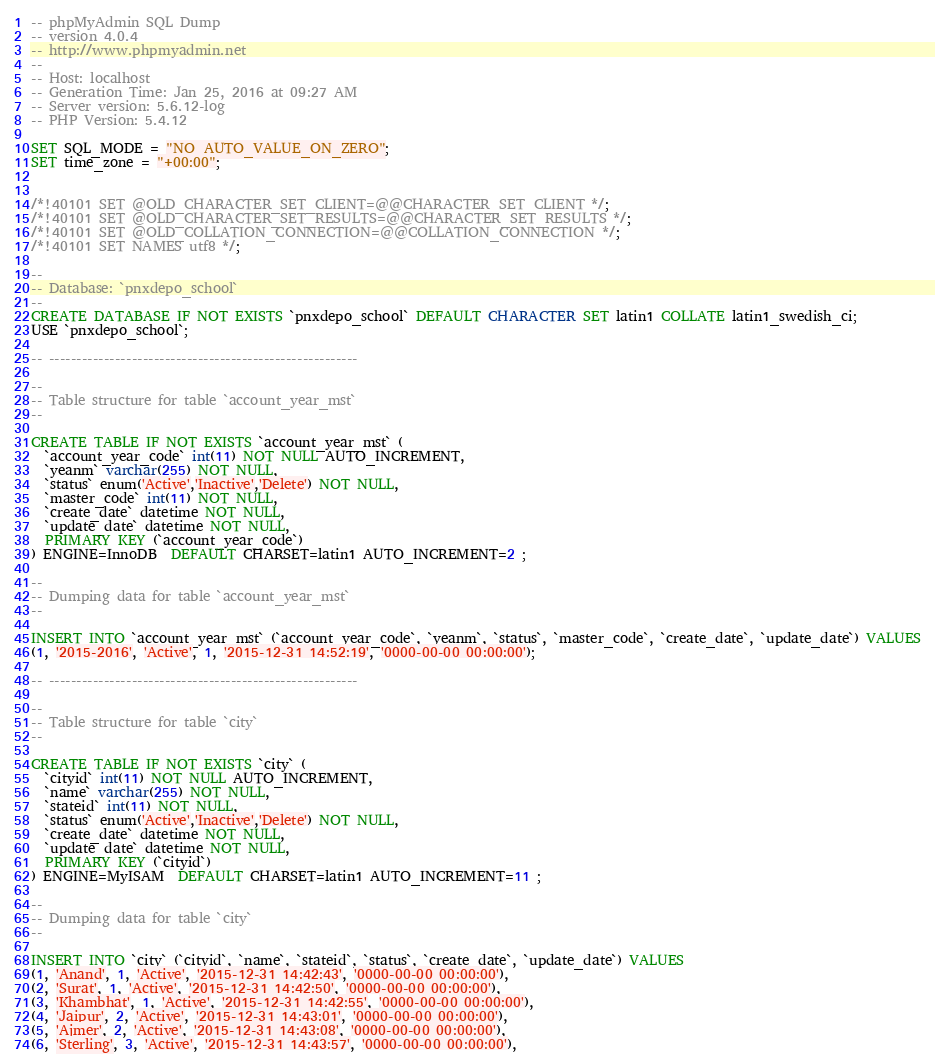<code> <loc_0><loc_0><loc_500><loc_500><_SQL_>-- phpMyAdmin SQL Dump
-- version 4.0.4
-- http://www.phpmyadmin.net
--
-- Host: localhost
-- Generation Time: Jan 25, 2016 at 09:27 AM
-- Server version: 5.6.12-log
-- PHP Version: 5.4.12

SET SQL_MODE = "NO_AUTO_VALUE_ON_ZERO";
SET time_zone = "+00:00";


/*!40101 SET @OLD_CHARACTER_SET_CLIENT=@@CHARACTER_SET_CLIENT */;
/*!40101 SET @OLD_CHARACTER_SET_RESULTS=@@CHARACTER_SET_RESULTS */;
/*!40101 SET @OLD_COLLATION_CONNECTION=@@COLLATION_CONNECTION */;
/*!40101 SET NAMES utf8 */;

--
-- Database: `pnxdepo_school`
--
CREATE DATABASE IF NOT EXISTS `pnxdepo_school` DEFAULT CHARACTER SET latin1 COLLATE latin1_swedish_ci;
USE `pnxdepo_school`;

-- --------------------------------------------------------

--
-- Table structure for table `account_year_mst`
--

CREATE TABLE IF NOT EXISTS `account_year_mst` (
  `account_year_code` int(11) NOT NULL AUTO_INCREMENT,
  `yeanm` varchar(255) NOT NULL,
  `status` enum('Active','Inactive','Delete') NOT NULL,
  `master_code` int(11) NOT NULL,
  `create_date` datetime NOT NULL,
  `update_date` datetime NOT NULL,
  PRIMARY KEY (`account_year_code`)
) ENGINE=InnoDB  DEFAULT CHARSET=latin1 AUTO_INCREMENT=2 ;

--
-- Dumping data for table `account_year_mst`
--

INSERT INTO `account_year_mst` (`account_year_code`, `yeanm`, `status`, `master_code`, `create_date`, `update_date`) VALUES
(1, '2015-2016', 'Active', 1, '2015-12-31 14:52:19', '0000-00-00 00:00:00');

-- --------------------------------------------------------

--
-- Table structure for table `city`
--

CREATE TABLE IF NOT EXISTS `city` (
  `cityid` int(11) NOT NULL AUTO_INCREMENT,
  `name` varchar(255) NOT NULL,
  `stateid` int(11) NOT NULL,
  `status` enum('Active','Inactive','Delete') NOT NULL,
  `create_date` datetime NOT NULL,
  `update_date` datetime NOT NULL,
  PRIMARY KEY (`cityid`)
) ENGINE=MyISAM  DEFAULT CHARSET=latin1 AUTO_INCREMENT=11 ;

--
-- Dumping data for table `city`
--

INSERT INTO `city` (`cityid`, `name`, `stateid`, `status`, `create_date`, `update_date`) VALUES
(1, 'Anand', 1, 'Active', '2015-12-31 14:42:43', '0000-00-00 00:00:00'),
(2, 'Surat', 1, 'Active', '2015-12-31 14:42:50', '0000-00-00 00:00:00'),
(3, 'Khambhat', 1, 'Active', '2015-12-31 14:42:55', '0000-00-00 00:00:00'),
(4, 'Jaipur', 2, 'Active', '2015-12-31 14:43:01', '0000-00-00 00:00:00'),
(5, 'Ajmer', 2, 'Active', '2015-12-31 14:43:08', '0000-00-00 00:00:00'),
(6, 'Sterling', 3, 'Active', '2015-12-31 14:43:57', '0000-00-00 00:00:00'),</code> 